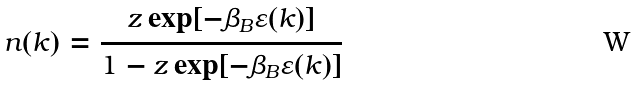Convert formula to latex. <formula><loc_0><loc_0><loc_500><loc_500>n ( k ) = \frac { z \exp [ - \beta _ { B } \varepsilon ( k ) ] } { 1 - z \exp [ - \beta _ { B } \varepsilon ( k ) ] }</formula> 